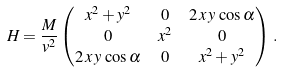Convert formula to latex. <formula><loc_0><loc_0><loc_500><loc_500>H & = \frac { M } { v ^ { 2 } } \begin{pmatrix} x ^ { 2 } + y ^ { 2 } & 0 & 2 \, x \, y \, \cos \alpha \\ 0 & x ^ { 2 } & 0 \\ 2 \, x \, y \, \cos \alpha & 0 & x ^ { 2 } + y ^ { 2 } \end{pmatrix} \, .</formula> 